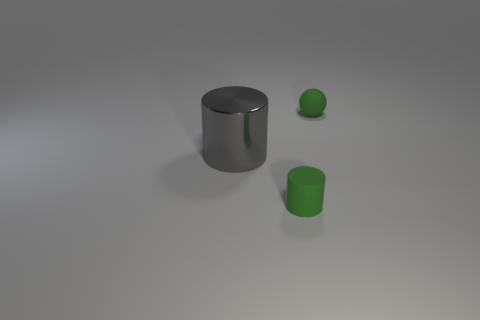Subtract all cylinders. How many objects are left? 1 Subtract 1 spheres. How many spheres are left? 0 Subtract all yellow balls. Subtract all gray blocks. How many balls are left? 1 Subtract all cyan blocks. How many gray cylinders are left? 1 Subtract all large objects. Subtract all big gray metallic cylinders. How many objects are left? 1 Add 3 tiny green spheres. How many tiny green spheres are left? 4 Add 3 brown matte balls. How many brown matte balls exist? 3 Add 2 big yellow metallic things. How many objects exist? 5 Subtract all gray cylinders. How many cylinders are left? 1 Subtract 0 green cubes. How many objects are left? 3 